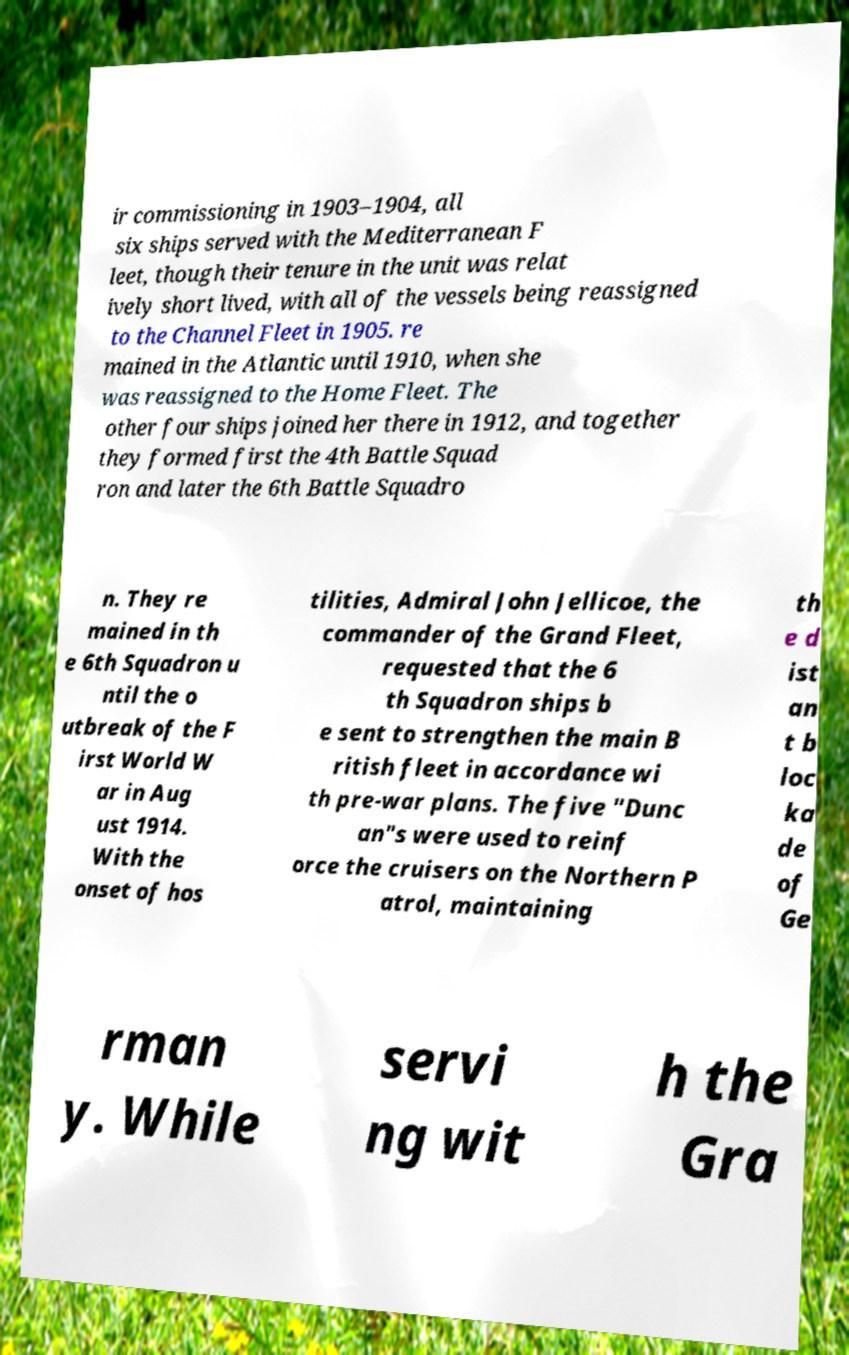What messages or text are displayed in this image? I need them in a readable, typed format. ir commissioning in 1903–1904, all six ships served with the Mediterranean F leet, though their tenure in the unit was relat ively short lived, with all of the vessels being reassigned to the Channel Fleet in 1905. re mained in the Atlantic until 1910, when she was reassigned to the Home Fleet. The other four ships joined her there in 1912, and together they formed first the 4th Battle Squad ron and later the 6th Battle Squadro n. They re mained in th e 6th Squadron u ntil the o utbreak of the F irst World W ar in Aug ust 1914. With the onset of hos tilities, Admiral John Jellicoe, the commander of the Grand Fleet, requested that the 6 th Squadron ships b e sent to strengthen the main B ritish fleet in accordance wi th pre-war plans. The five "Dunc an"s were used to reinf orce the cruisers on the Northern P atrol, maintaining th e d ist an t b loc ka de of Ge rman y. While servi ng wit h the Gra 